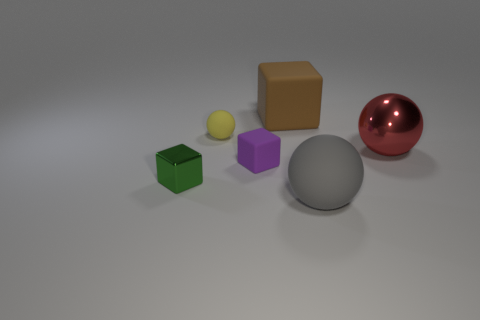Subtract all large red metallic spheres. How many spheres are left? 2 Add 1 purple objects. How many objects exist? 7 Subtract all red balls. How many balls are left? 2 Subtract all blue balls. Subtract all purple cubes. How many balls are left? 3 Subtract all red cubes. How many gray spheres are left? 1 Subtract all large gray cylinders. Subtract all large brown blocks. How many objects are left? 5 Add 4 big red shiny things. How many big red shiny things are left? 5 Add 3 large purple shiny spheres. How many large purple shiny spheres exist? 3 Subtract 1 purple cubes. How many objects are left? 5 Subtract 1 cubes. How many cubes are left? 2 